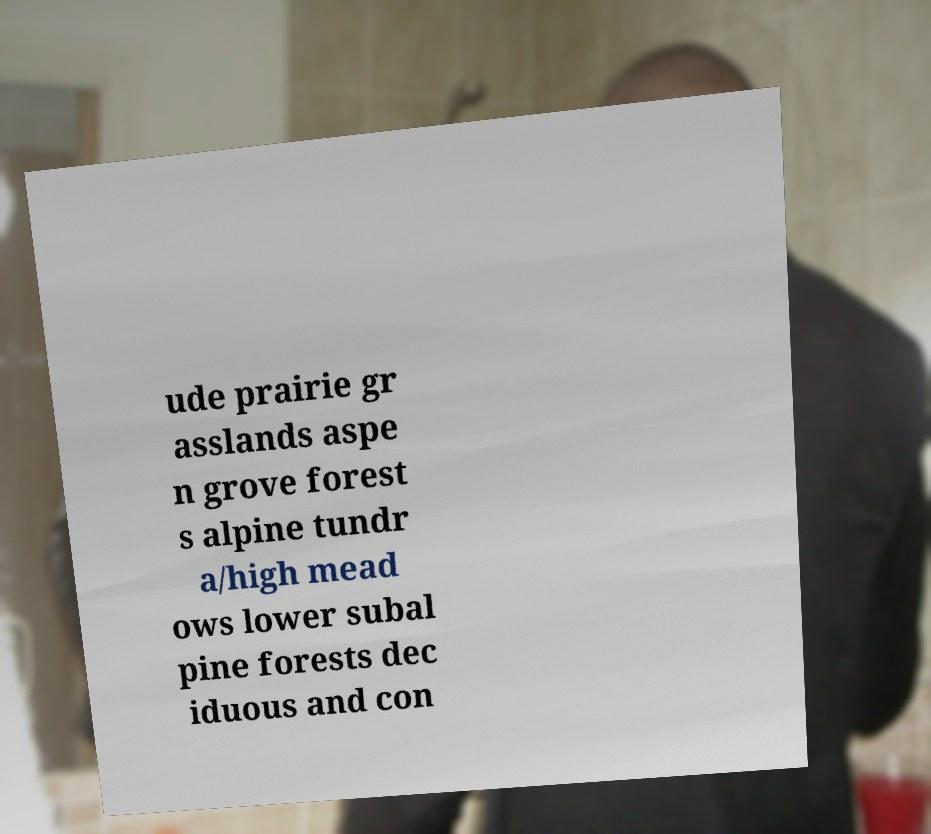There's text embedded in this image that I need extracted. Can you transcribe it verbatim? ude prairie gr asslands aspe n grove forest s alpine tundr a/high mead ows lower subal pine forests dec iduous and con 